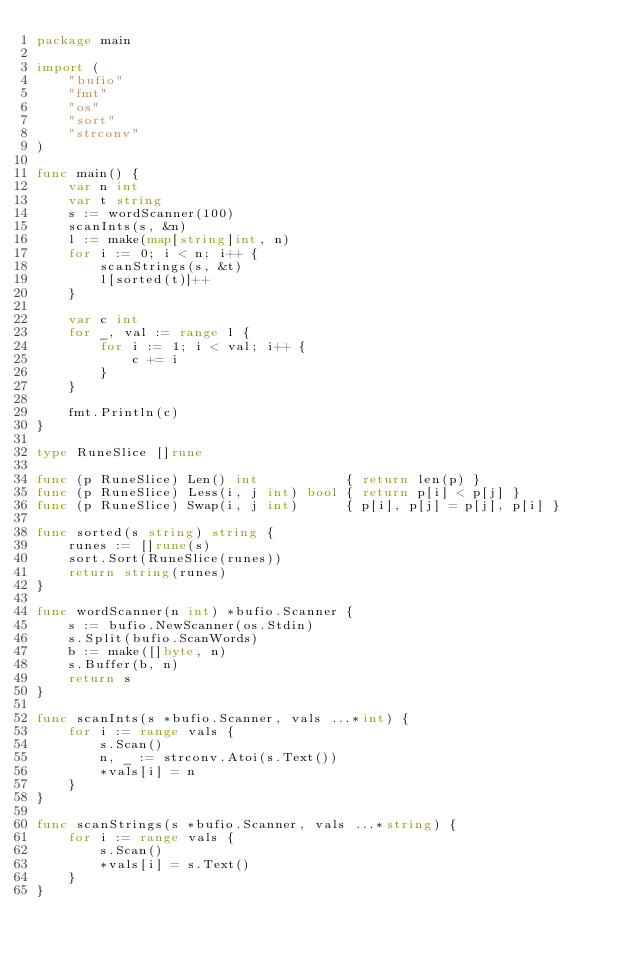Convert code to text. <code><loc_0><loc_0><loc_500><loc_500><_Go_>package main

import (
	"bufio"
	"fmt"
	"os"
	"sort"
	"strconv"
)

func main() {
	var n int
	var t string
	s := wordScanner(100)
	scanInts(s, &n)
	l := make(map[string]int, n)
	for i := 0; i < n; i++ {
		scanStrings(s, &t)
		l[sorted(t)]++
	}

	var c int
	for _, val := range l {
		for i := 1; i < val; i++ {
			c += i
		}
	}

	fmt.Println(c)
}

type RuneSlice []rune

func (p RuneSlice) Len() int           { return len(p) }
func (p RuneSlice) Less(i, j int) bool { return p[i] < p[j] }
func (p RuneSlice) Swap(i, j int)      { p[i], p[j] = p[j], p[i] }

func sorted(s string) string {
	runes := []rune(s)
	sort.Sort(RuneSlice(runes))
	return string(runes)
}

func wordScanner(n int) *bufio.Scanner {
	s := bufio.NewScanner(os.Stdin)
	s.Split(bufio.ScanWords)
	b := make([]byte, n)
	s.Buffer(b, n)
	return s
}

func scanInts(s *bufio.Scanner, vals ...*int) {
	for i := range vals {
		s.Scan()
		n, _ := strconv.Atoi(s.Text())
		*vals[i] = n
	}
}

func scanStrings(s *bufio.Scanner, vals ...*string) {
	for i := range vals {
		s.Scan()
		*vals[i] = s.Text()
	}
}
</code> 